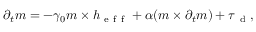<formula> <loc_0><loc_0><loc_500><loc_500>\partial _ { t } m = - \gamma _ { 0 } m \times h _ { e f f } + \alpha ( m \times \partial _ { t } m ) + \tau _ { d } ,</formula> 